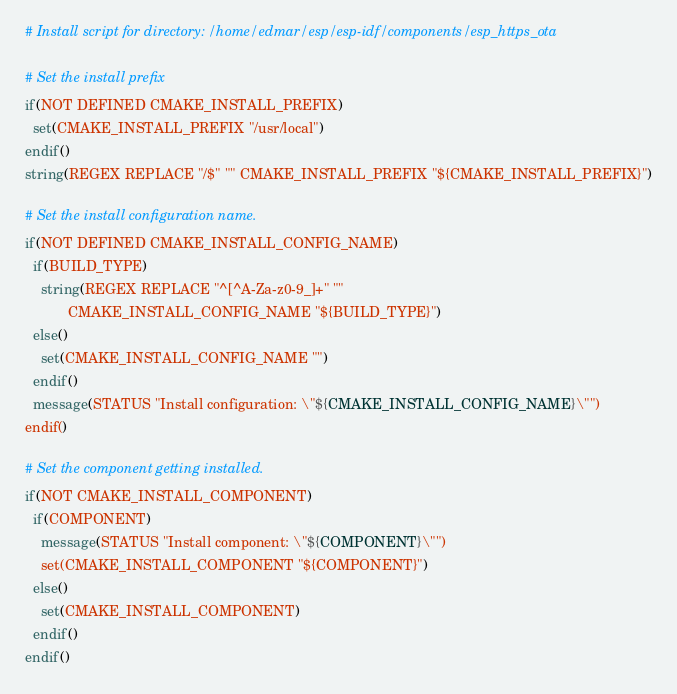<code> <loc_0><loc_0><loc_500><loc_500><_CMake_># Install script for directory: /home/edmar/esp/esp-idf/components/esp_https_ota

# Set the install prefix
if(NOT DEFINED CMAKE_INSTALL_PREFIX)
  set(CMAKE_INSTALL_PREFIX "/usr/local")
endif()
string(REGEX REPLACE "/$" "" CMAKE_INSTALL_PREFIX "${CMAKE_INSTALL_PREFIX}")

# Set the install configuration name.
if(NOT DEFINED CMAKE_INSTALL_CONFIG_NAME)
  if(BUILD_TYPE)
    string(REGEX REPLACE "^[^A-Za-z0-9_]+" ""
           CMAKE_INSTALL_CONFIG_NAME "${BUILD_TYPE}")
  else()
    set(CMAKE_INSTALL_CONFIG_NAME "")
  endif()
  message(STATUS "Install configuration: \"${CMAKE_INSTALL_CONFIG_NAME}\"")
endif()

# Set the component getting installed.
if(NOT CMAKE_INSTALL_COMPONENT)
  if(COMPONENT)
    message(STATUS "Install component: \"${COMPONENT}\"")
    set(CMAKE_INSTALL_COMPONENT "${COMPONENT}")
  else()
    set(CMAKE_INSTALL_COMPONENT)
  endif()
endif()

</code> 